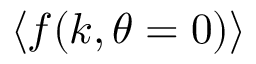Convert formula to latex. <formula><loc_0><loc_0><loc_500><loc_500>\left \langle f ( k , \theta = 0 ) \right \rangle</formula> 